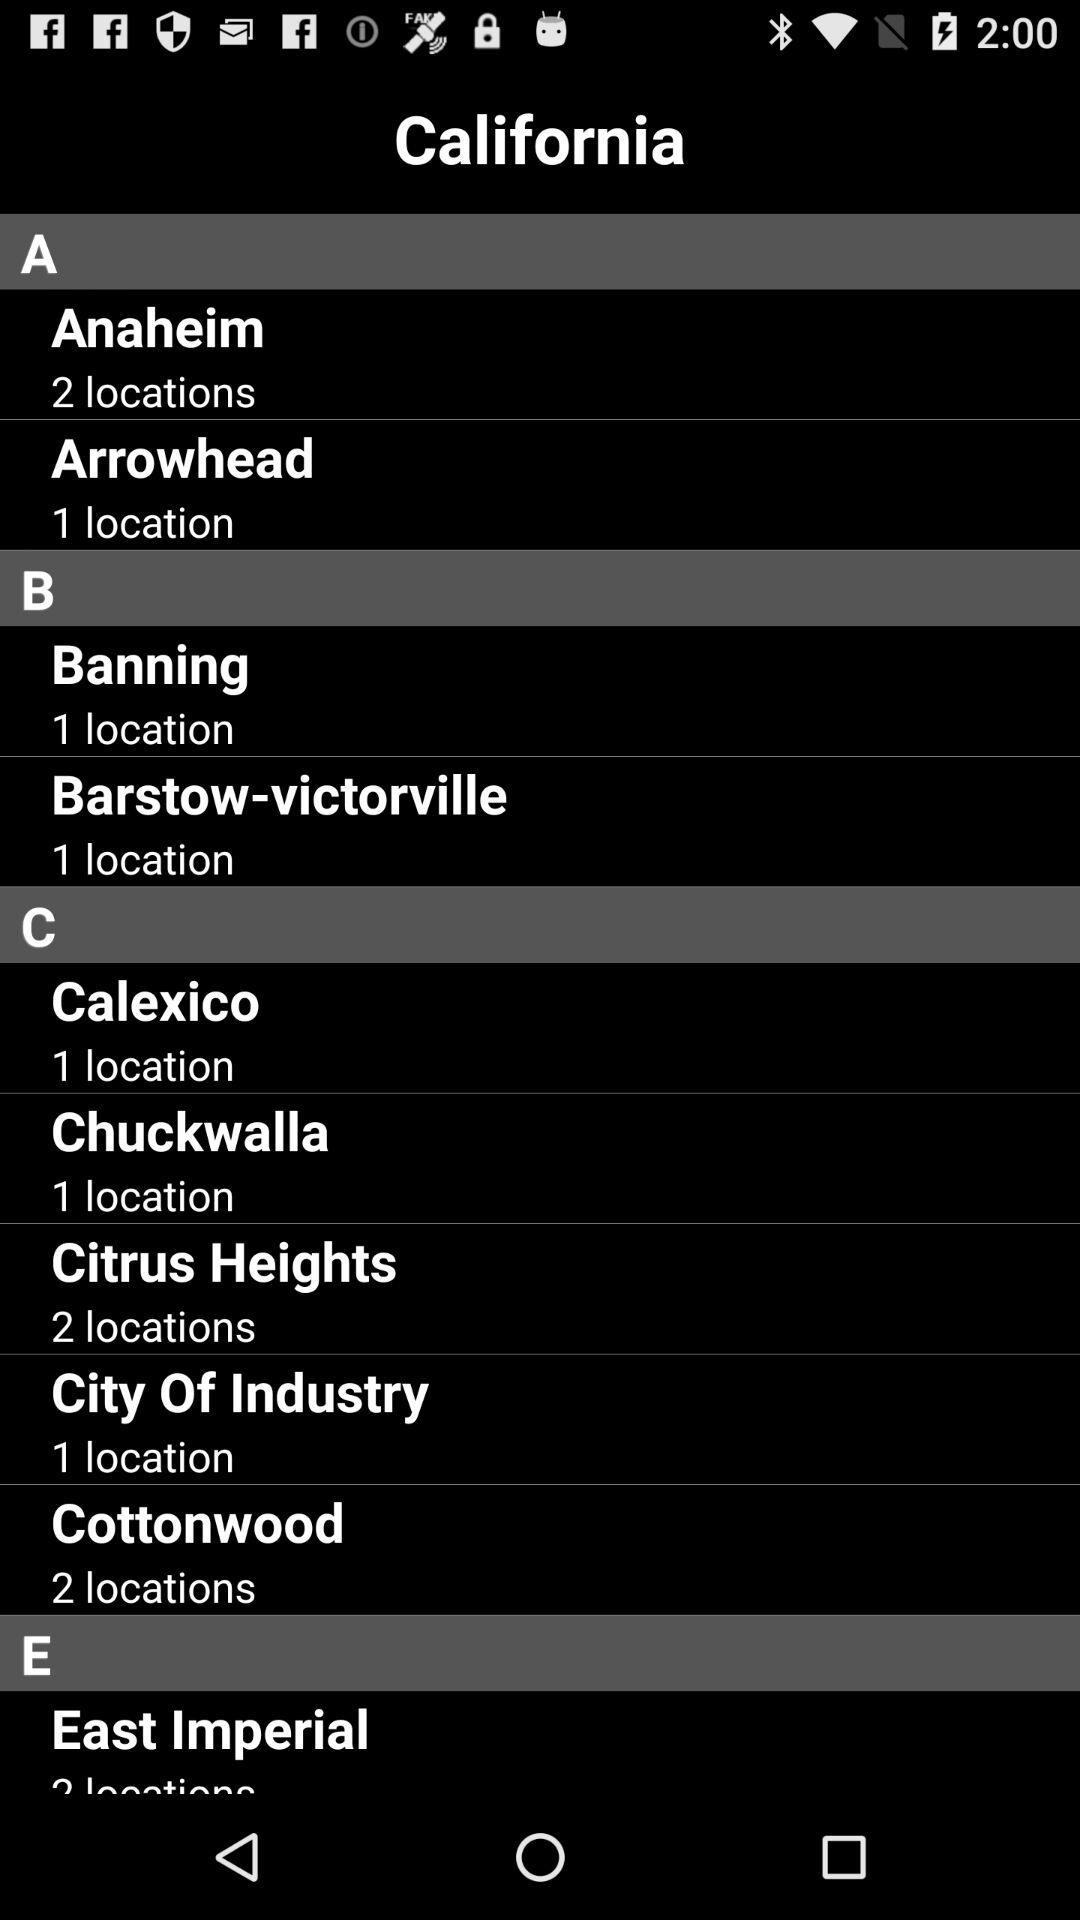How many locations are there in Anaheim? There are 2 locations in Anaheim. 